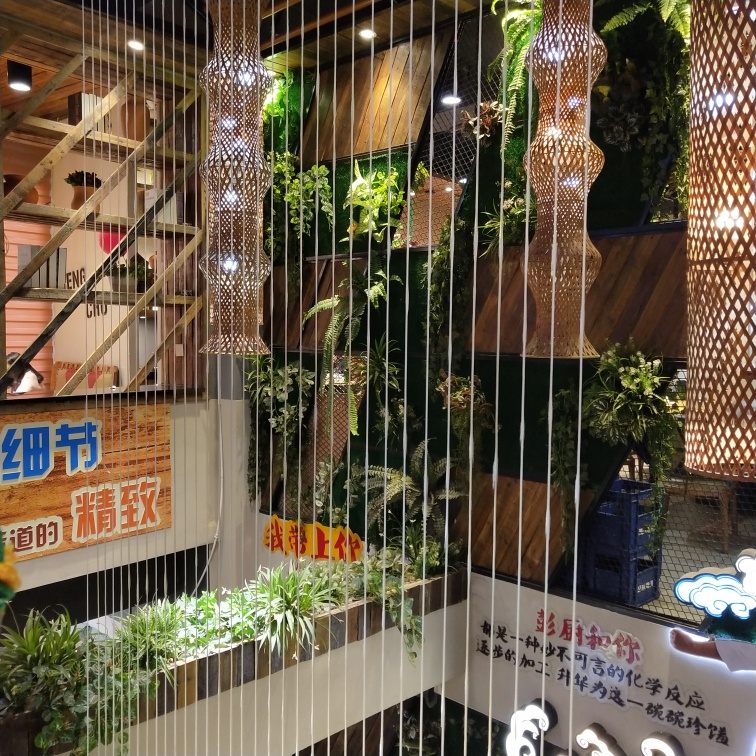How clear are the details of the advertising signs?
A. Blurry
B. Unclear
C. Very clear
Answer with the option's letter from the given choices directly.
 C. 